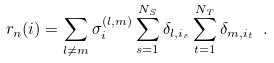Convert formula to latex. <formula><loc_0><loc_0><loc_500><loc_500>r _ { n } ( i ) = \sum _ { l \neq m } \sigma _ { i } ^ { ( l , m ) } \sum _ { s = 1 } ^ { N _ { S } } \delta _ { l , i _ { s } } \sum _ { t = 1 } ^ { N _ { T } } \delta _ { m , i _ { t } } \ .</formula> 